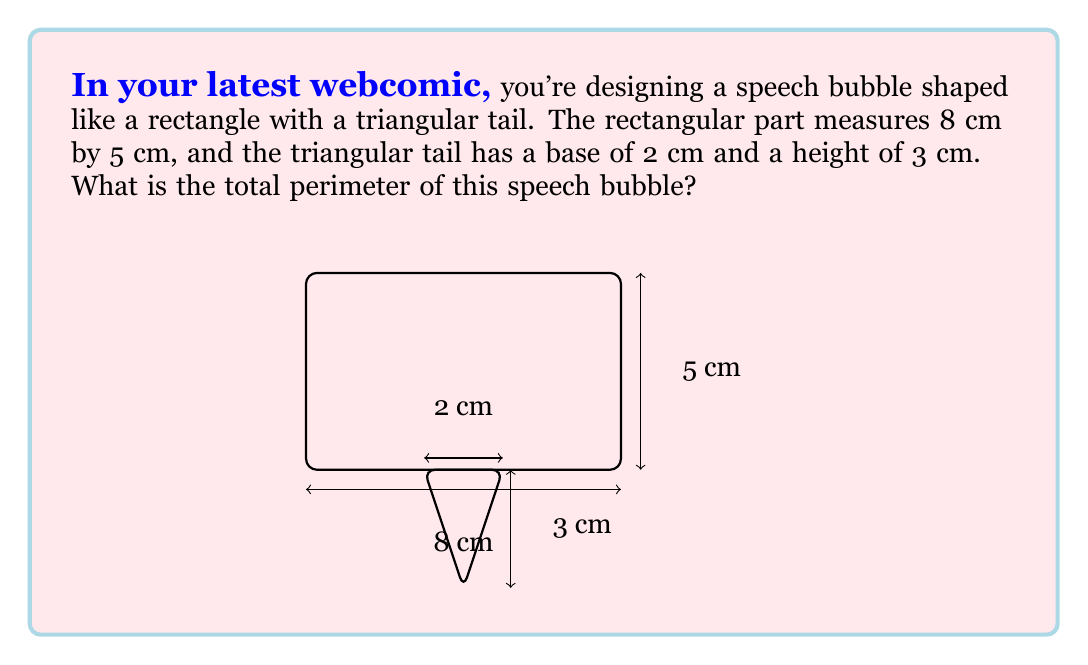Provide a solution to this math problem. Let's break this down step-by-step:

1) First, let's calculate the perimeter of the rectangular part:
   Perimeter of rectangle = $2(length + width)$
   $$ P_{rectangle} = 2(8 + 5) = 2(13) = 26 \text{ cm} $$

2) Now, we need to calculate the length of the two sides of the triangular tail:
   We can use the Pythagorean theorem. If we split the triangle in half, we have a right triangle with base 1 cm and height 3 cm.
   $$ side^2 = 1^2 + 3^2 = 1 + 9 = 10 $$
   $$ side = \sqrt{10} \text{ cm} $$

3) The triangular tail adds two of these sides to the perimeter, but subtracts the 2 cm base that's shared with the rectangle:
   Additional perimeter from tail = $2\sqrt{10} - 2$ cm

4) Total perimeter:
   $$ P_{total} = P_{rectangle} + (2\sqrt{10} - 2) $$
   $$ P_{total} = 26 + 2\sqrt{10} - 2 = 24 + 2\sqrt{10} \text{ cm} $$
Answer: $24 + 2\sqrt{10}$ cm 